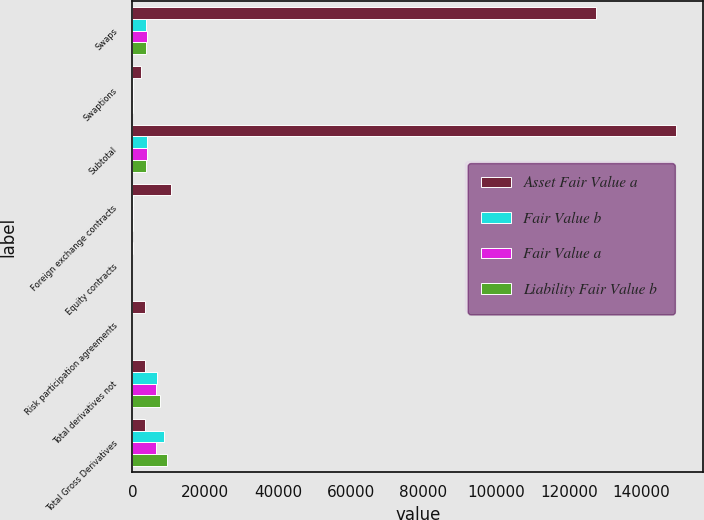Convert chart. <chart><loc_0><loc_0><loc_500><loc_500><stacked_bar_chart><ecel><fcel>Swaps<fcel>Swaptions<fcel>Subtotal<fcel>Foreign exchange contracts<fcel>Equity contracts<fcel>Risk participation agreements<fcel>Total derivatives not<fcel>Total Gross Derivatives<nl><fcel>Asset Fair Value a<fcel>127567<fcel>2285<fcel>149476<fcel>10737<fcel>105<fcel>3530<fcel>3589.5<fcel>3589.5<nl><fcel>Fair Value b<fcel>3869<fcel>82<fcel>3974<fcel>126<fcel>1<fcel>5<fcel>6696<fcel>8568<nl><fcel>Fair Value a<fcel>3917<fcel>35<fcel>3955<fcel>112<fcel>3<fcel>6<fcel>6458<fcel>6610<nl><fcel>Liability Fair Value b<fcel>3649<fcel>136<fcel>3804<fcel>231<fcel>5<fcel>6<fcel>7575<fcel>9463<nl></chart> 